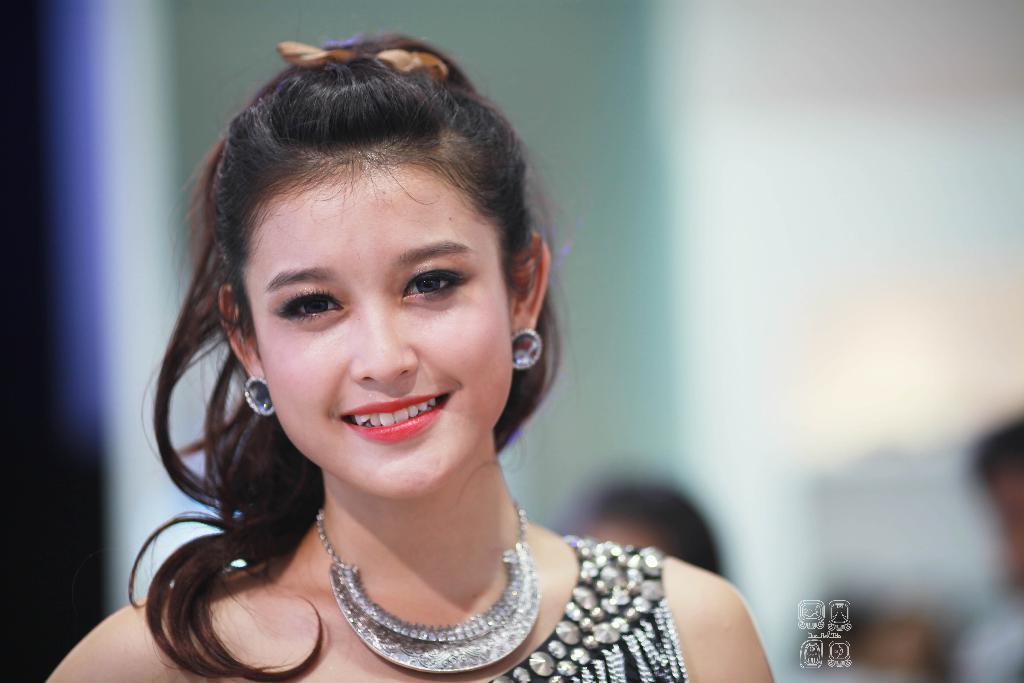Describe this image in one or two sentences. This woman is smiling and looking forward. Background it is blur. Here we can see watermark. 